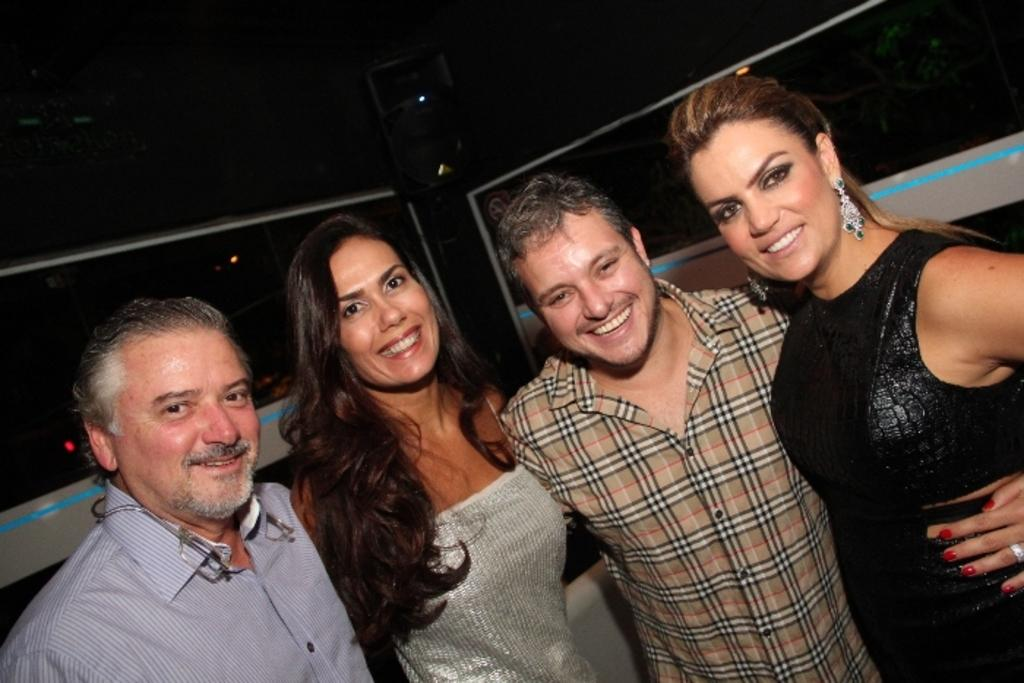What is happening in the foreground of the image? There are people standing in the foreground of the image. What can be seen in the background of the image? There are walls visible in the background of the image. How many brothers are visible in the image? There is no mention of brothers in the image, so we cannot determine the number of brothers present. What type of root can be seen growing on the walls in the image? There is no root visible on the walls in the image. 